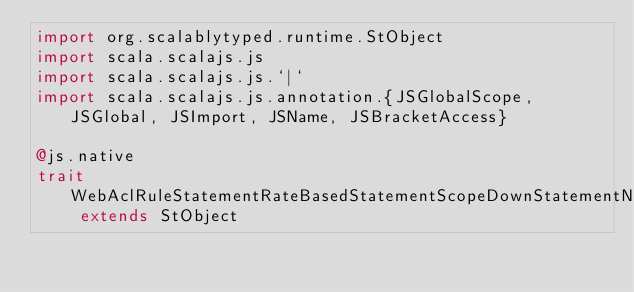<code> <loc_0><loc_0><loc_500><loc_500><_Scala_>import org.scalablytyped.runtime.StObject
import scala.scalajs.js
import scala.scalajs.js.`|`
import scala.scalajs.js.annotation.{JSGlobalScope, JSGlobal, JSImport, JSName, JSBracketAccess}

@js.native
trait WebAclRuleStatementRateBasedStatementScopeDownStatementNotStatementStatementNotStatementStatementXssMatchStatementFieldToMatchBody extends StObject
</code> 